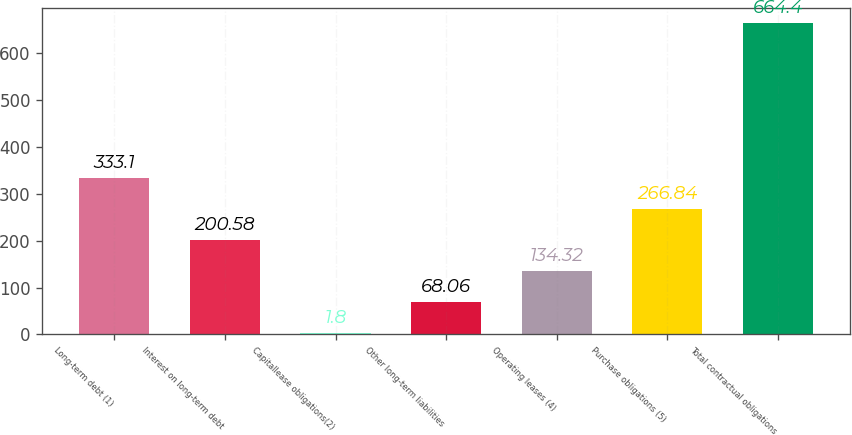<chart> <loc_0><loc_0><loc_500><loc_500><bar_chart><fcel>Long-term debt (1)<fcel>Interest on long-term debt<fcel>Capitallease obligations(2)<fcel>Other long-term liabilities<fcel>Operating leases (4)<fcel>Purchase obligations (5)<fcel>Total contractual obligations<nl><fcel>333.1<fcel>200.58<fcel>1.8<fcel>68.06<fcel>134.32<fcel>266.84<fcel>664.4<nl></chart> 